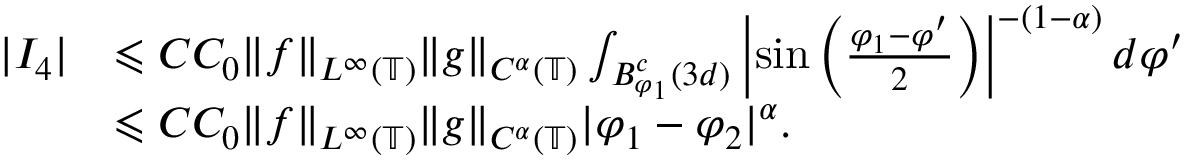Convert formula to latex. <formula><loc_0><loc_0><loc_500><loc_500>\begin{array} { r l } { | I _ { 4 } | } & { \leqslant C C _ { 0 } \| f \| _ { L ^ { \infty } ( \mathbb { T } ) } \| g \| _ { C ^ { \alpha } ( \mathbb { T } ) } \int _ { B _ { \varphi _ { 1 } } ^ { c } ( 3 d ) } \left | \sin \left ( \frac { \varphi _ { 1 } - \varphi ^ { \prime } } { 2 } \right ) \right | ^ { - ( 1 - \alpha ) } d \varphi ^ { \prime } } \\ & { \leqslant C C _ { 0 } \| f \| _ { L ^ { \infty } ( \mathbb { T } ) } \| g \| _ { C ^ { \alpha } ( \mathbb { T } ) } | \varphi _ { 1 } - \varphi _ { 2 } | ^ { \alpha } . } \end{array}</formula> 